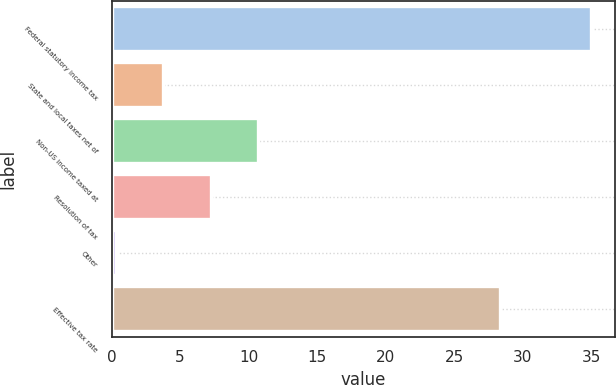Convert chart to OTSL. <chart><loc_0><loc_0><loc_500><loc_500><bar_chart><fcel>Federal statutory income tax<fcel>State and local taxes net of<fcel>Non-US income taxed at<fcel>Resolution of tax<fcel>Other<fcel>Effective tax rate<nl><fcel>35<fcel>3.77<fcel>10.71<fcel>7.24<fcel>0.3<fcel>28.3<nl></chart> 